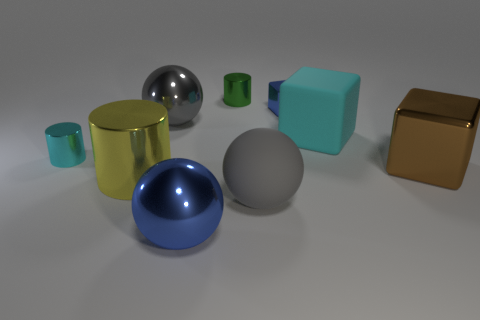Which shapes are present and which object stands out the most? The image includes several geometric shapes: there are spheres, cubes, and a cylinder. The object that stands out the most is the large aqua rubber block due to its vibrant color and prominent placement in the center of the composition. What does the arrangement of objects tell us about the scene? The arrangement of objects appears to be intentionally scattered, likely to display varying shapes, materials, and colors for visual comparison or for an aesthetic purpose such as a still life art piece or a material study in a 3D rendering context. 